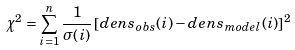Convert formula to latex. <formula><loc_0><loc_0><loc_500><loc_500>\chi ^ { 2 } = \sum _ { i = 1 } ^ { n } \frac { 1 } { \sigma ( i ) } \left [ d e n s _ { o b s } ( i ) - d e n s _ { m o d e l } ( i ) \right ] ^ { 2 }</formula> 